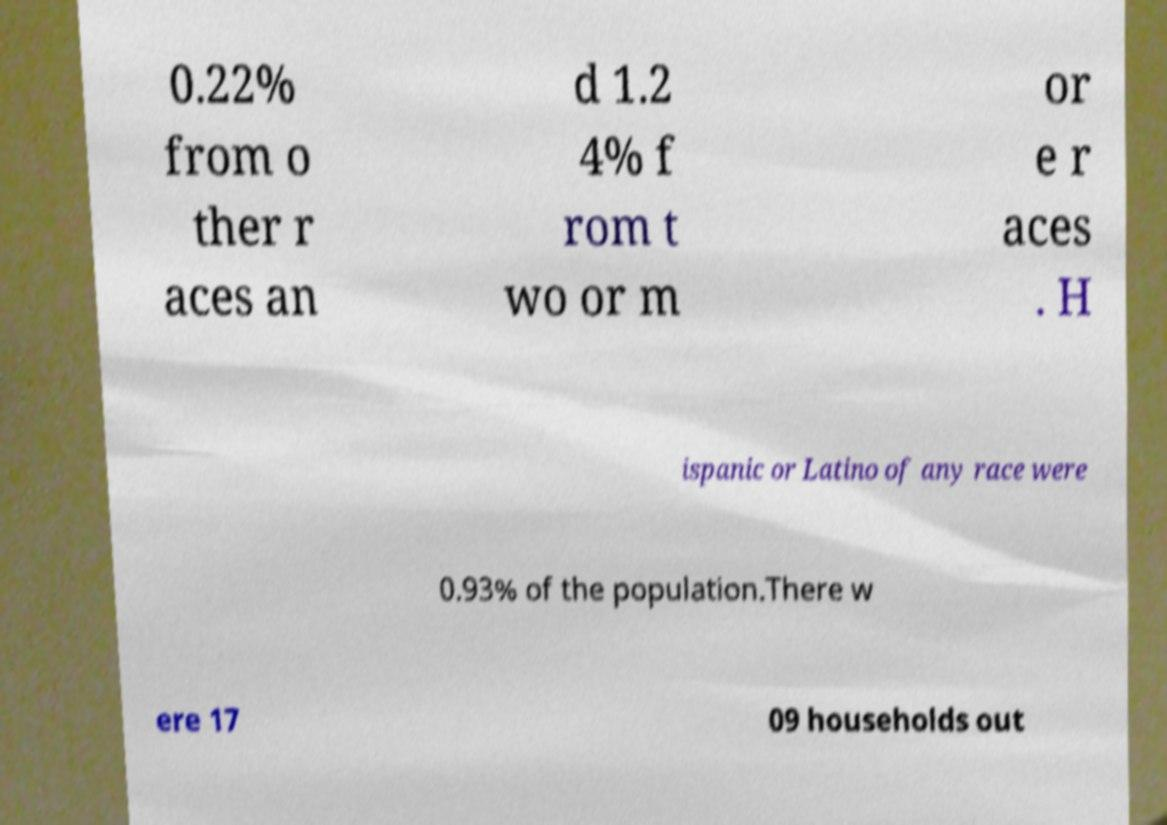What messages or text are displayed in this image? I need them in a readable, typed format. 0.22% from o ther r aces an d 1.2 4% f rom t wo or m or e r aces . H ispanic or Latino of any race were 0.93% of the population.There w ere 17 09 households out 